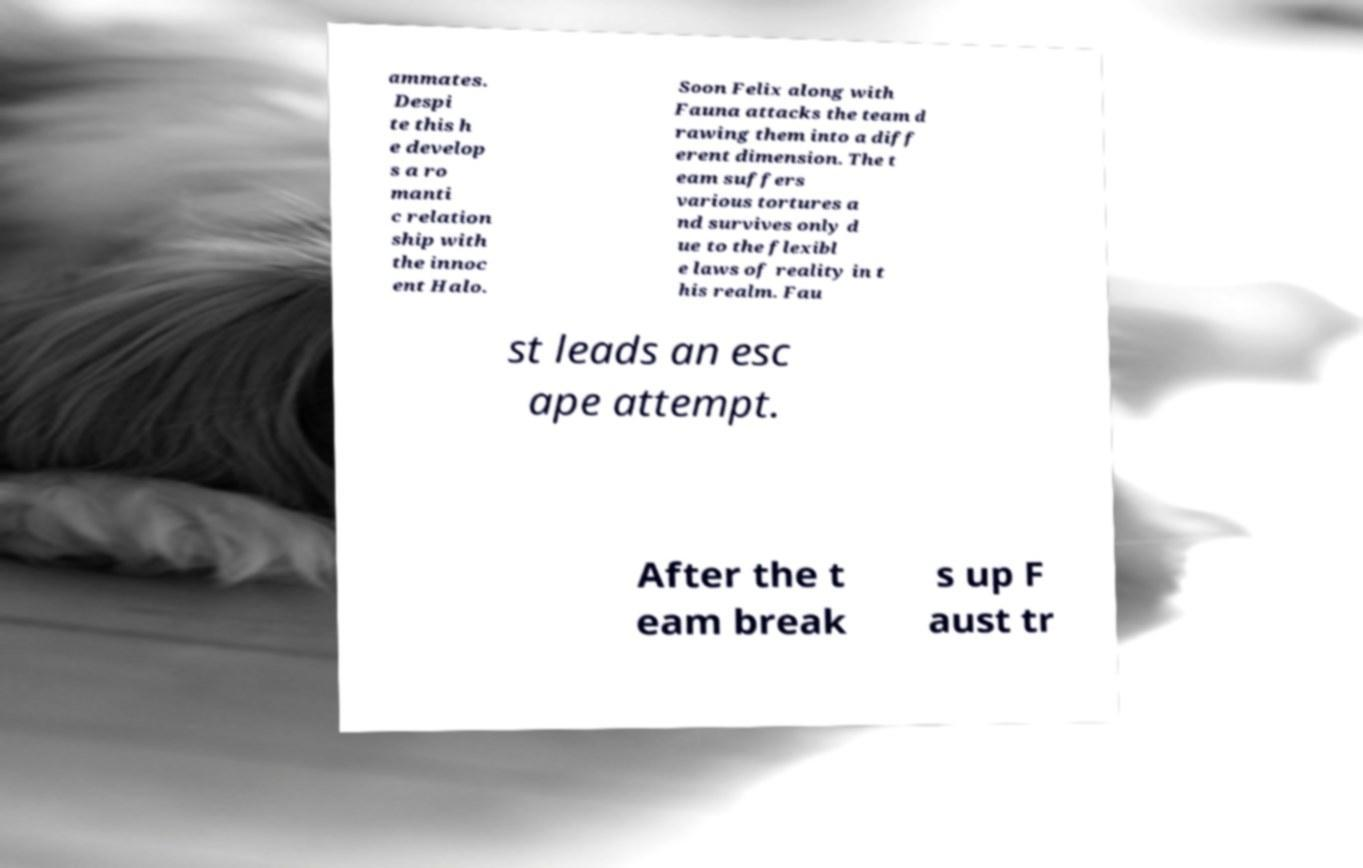Can you accurately transcribe the text from the provided image for me? ammates. Despi te this h e develop s a ro manti c relation ship with the innoc ent Halo. Soon Felix along with Fauna attacks the team d rawing them into a diff erent dimension. The t eam suffers various tortures a nd survives only d ue to the flexibl e laws of reality in t his realm. Fau st leads an esc ape attempt. After the t eam break s up F aust tr 